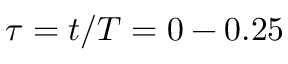Convert formula to latex. <formula><loc_0><loc_0><loc_500><loc_500>\tau = t / T = 0 - 0 . 2 5</formula> 